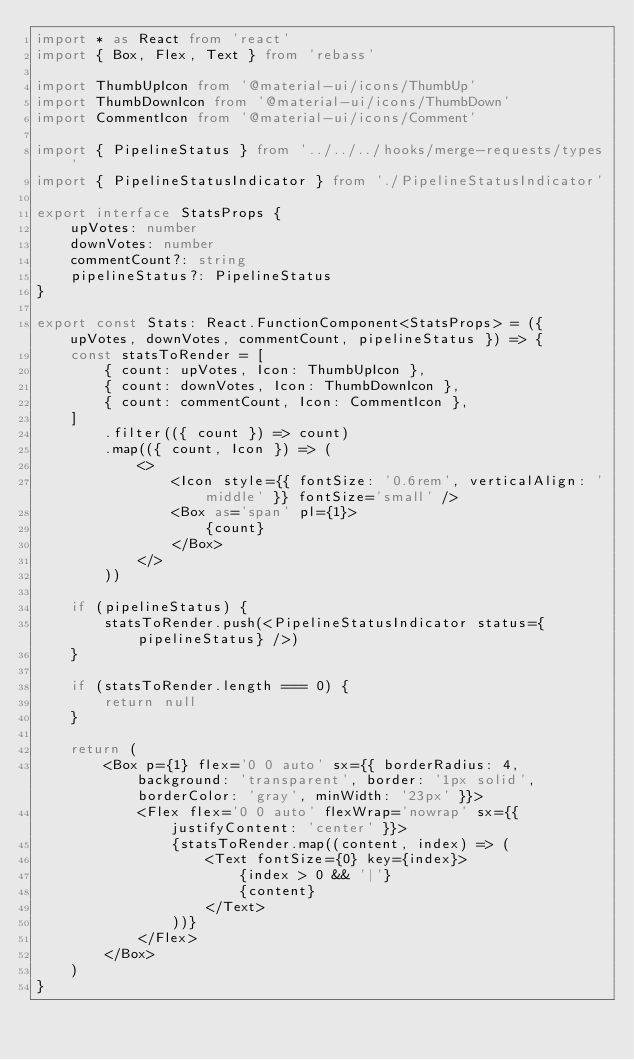Convert code to text. <code><loc_0><loc_0><loc_500><loc_500><_TypeScript_>import * as React from 'react'
import { Box, Flex, Text } from 'rebass'

import ThumbUpIcon from '@material-ui/icons/ThumbUp'
import ThumbDownIcon from '@material-ui/icons/ThumbDown'
import CommentIcon from '@material-ui/icons/Comment'

import { PipelineStatus } from '../../../hooks/merge-requests/types'
import { PipelineStatusIndicator } from './PipelineStatusIndicator'

export interface StatsProps {
    upVotes: number
    downVotes: number
    commentCount?: string
    pipelineStatus?: PipelineStatus
}

export const Stats: React.FunctionComponent<StatsProps> = ({ upVotes, downVotes, commentCount, pipelineStatus }) => {
    const statsToRender = [
        { count: upVotes, Icon: ThumbUpIcon },
        { count: downVotes, Icon: ThumbDownIcon },
        { count: commentCount, Icon: CommentIcon },
    ]
        .filter(({ count }) => count)
        .map(({ count, Icon }) => (
            <>
                <Icon style={{ fontSize: '0.6rem', verticalAlign: 'middle' }} fontSize='small' />
                <Box as='span' pl={1}>
                    {count}
                </Box>
            </>
        ))

    if (pipelineStatus) {
        statsToRender.push(<PipelineStatusIndicator status={pipelineStatus} />)
    }

    if (statsToRender.length === 0) {
        return null
    }

    return (
        <Box p={1} flex='0 0 auto' sx={{ borderRadius: 4, background: 'transparent', border: '1px solid', borderColor: 'gray', minWidth: '23px' }}>
            <Flex flex='0 0 auto' flexWrap='nowrap' sx={{ justifyContent: 'center' }}>
                {statsToRender.map((content, index) => (
                    <Text fontSize={0} key={index}>
                        {index > 0 && '|'}
                        {content}
                    </Text>
                ))}
            </Flex>
        </Box>
    )
}
</code> 